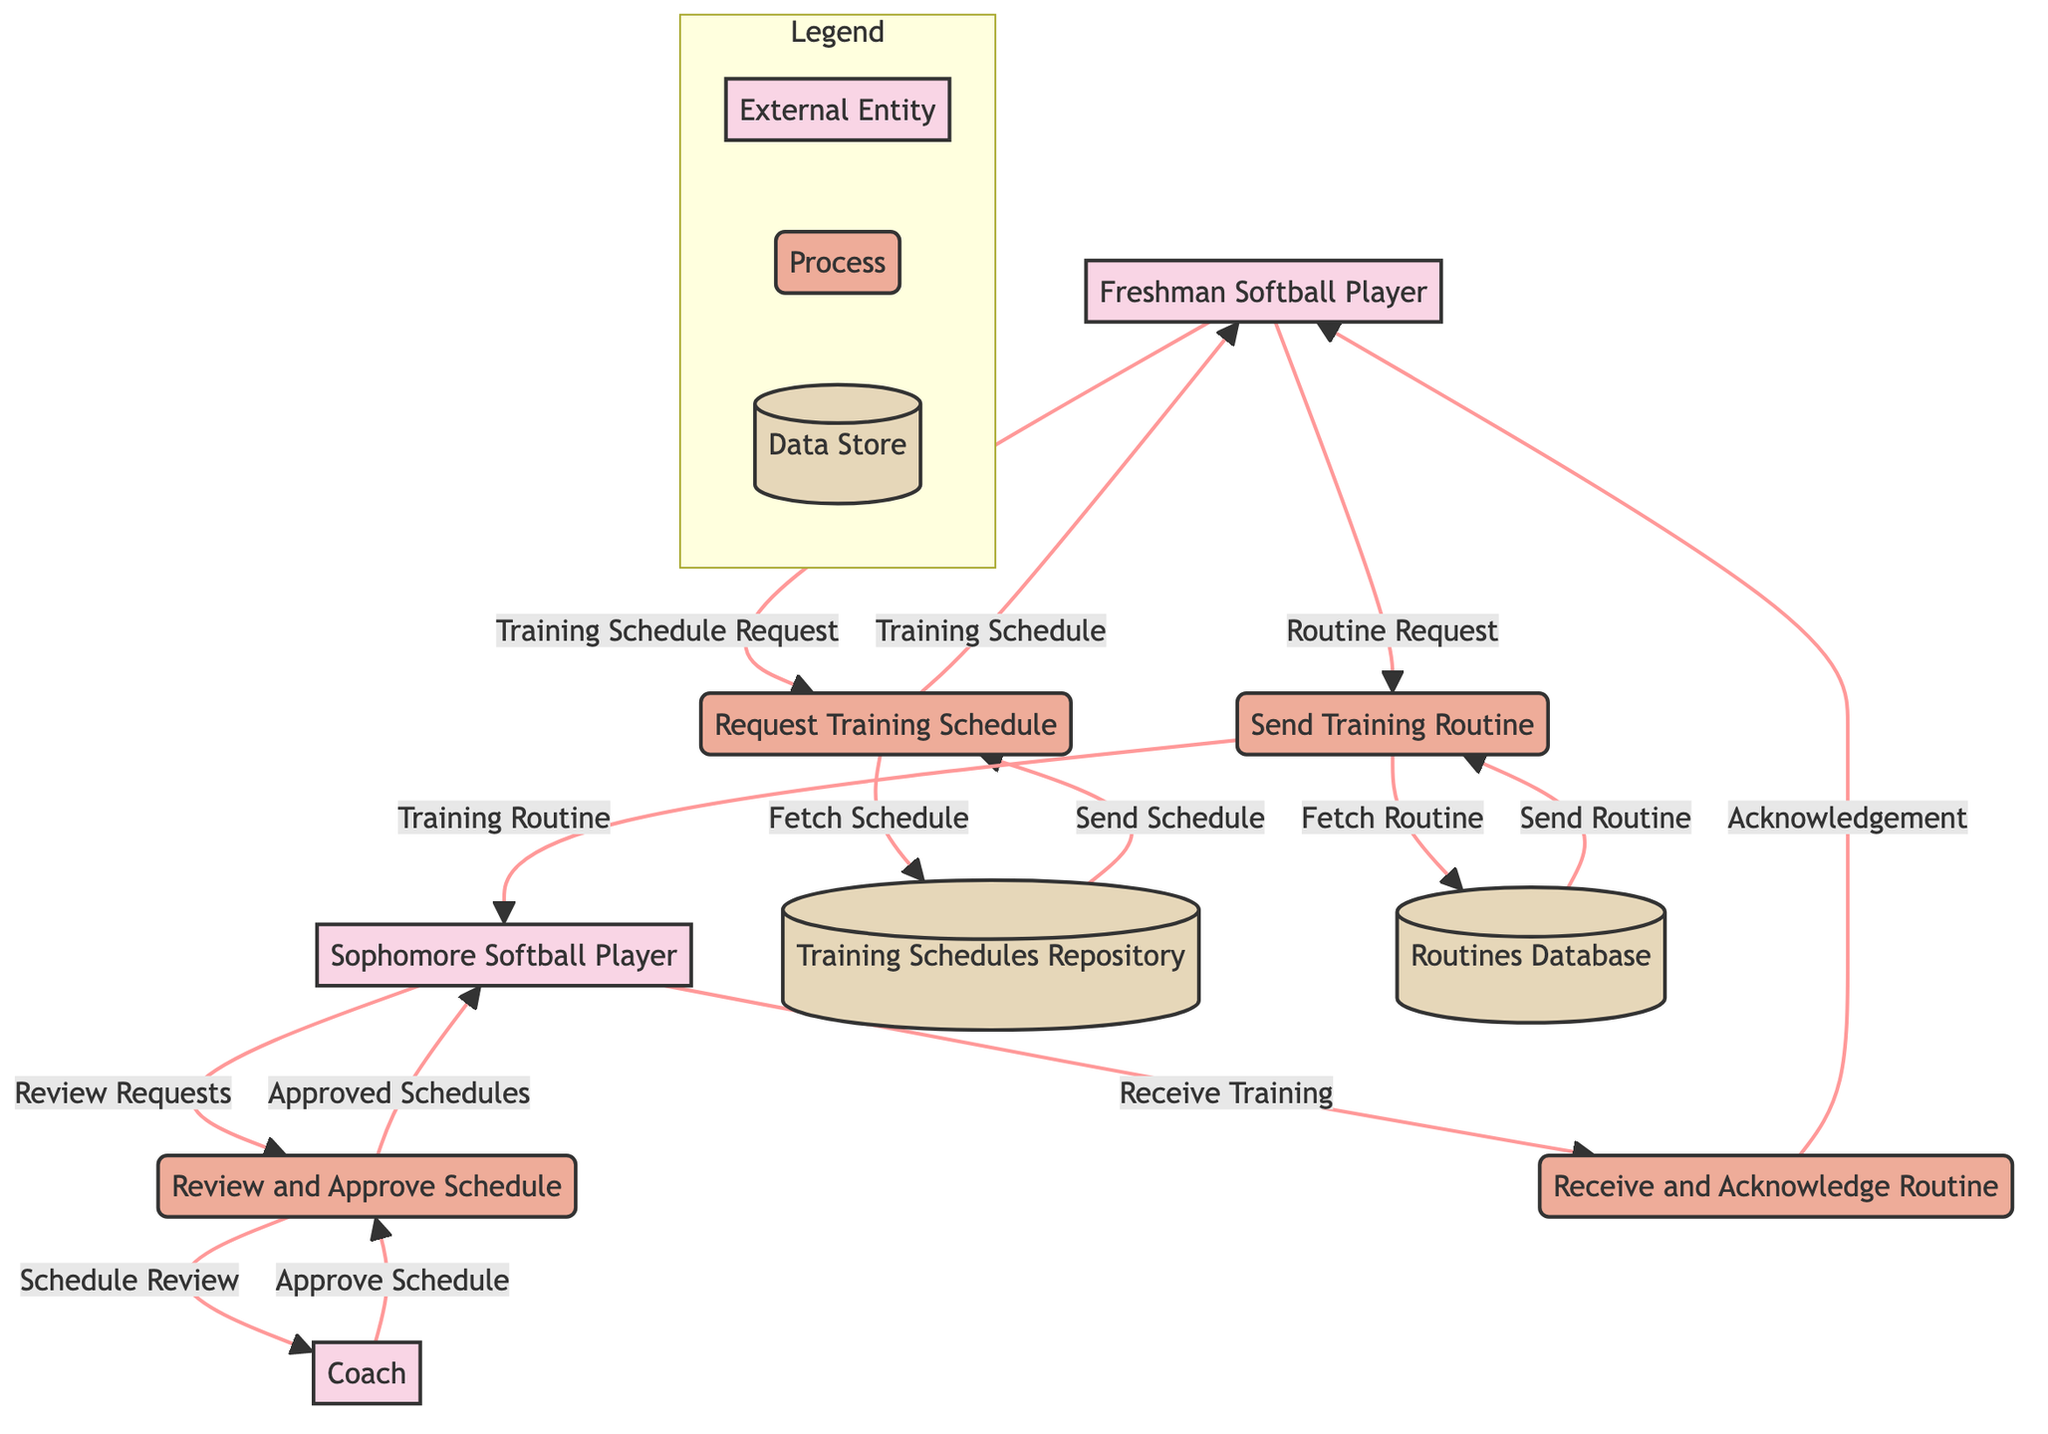What are the external entities in this diagram? The diagram identifies three external entities: Freshman Softball Player, Sophomore Softball Player, and Coach. This can be observed as they are labeled as entities.
Answer: Freshman Softball Player, Sophomore Softball Player, Coach How many processes are shown in the diagram? The diagram includes four processes: Request Training Schedule, Send Training Routine, Review and Approve Schedule, and Receive and Acknowledge Routine. By counting the labeled processes, we confirm there are four.
Answer: Four What instruction does the Freshman Softball Player send to get the training schedule? The Freshman Softball Player sends a "Training Schedule Request" to initiate the process. This is indicated by the arc connecting the Freshman Softball Player to the Request Training Schedule process with that label.
Answer: Training Schedule Request Which data store is associated with sending the training routine? The Routines Database is the data store linked to the Send Training Routine process. This is indicated by the connection flowing from the Send Training Routine process to the Routines Database with the label "Fetch Routine."
Answer: Routines Database Explain the sequence from the Sophomore Softball Player to the Coach in the process. The Sophomore Softball Player reviews requests and sends it to the Review and Approve Schedule process. The review sends a "Schedule Review" to the Coach. The Coach then approves the schedule and sends approved schedules back to the Sophomore Softball Player. This shows a clear flow of review, action, and feedback.
Answer: Review, Schedule Review, Approve Schedule, Approved Schedules How does the Freshman Softball Player receive acknowledgment after sending a routine request? After the Freshman Softball Player sends a Routine Request, the Send Training Routine process sends the Training Routine to the Sophomore Softball Player. The Sophomore then acknowledges it through the Receive and Acknowledge Routine process, which returns the acknowledgment to the Freshman. This establishes a complete communication loop.
Answer: Acknowledgment What is the role of the Coach in the training schedule process? The Coach's role is to review the training schedules submitted by the Sophomore Softball Player and approve them. This is evidenced by the flow showing the "Schedule Review" being sent to the Coach and the "Approve Schedule" coming back.
Answer: Schedule Review, Approve Schedule Identify the flow that indicates the fetching of the training schedule. The flow that indicates fetching the training schedule is labeled "Fetch Schedule." It connects the Request Training Schedule process to the Training Schedules Repository. This flow shows how the system retrieves the necessary schedules from storage.
Answer: Fetch Schedule 